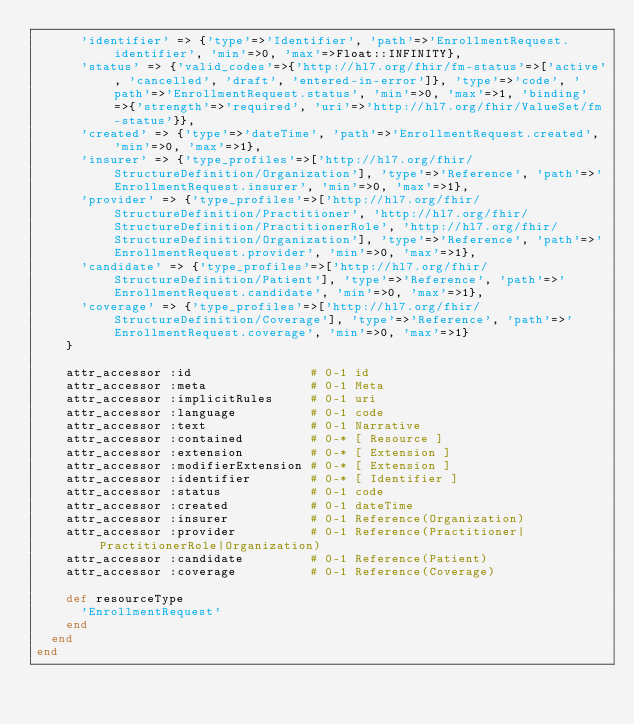<code> <loc_0><loc_0><loc_500><loc_500><_Ruby_>      'identifier' => {'type'=>'Identifier', 'path'=>'EnrollmentRequest.identifier', 'min'=>0, 'max'=>Float::INFINITY},
      'status' => {'valid_codes'=>{'http://hl7.org/fhir/fm-status'=>['active', 'cancelled', 'draft', 'entered-in-error']}, 'type'=>'code', 'path'=>'EnrollmentRequest.status', 'min'=>0, 'max'=>1, 'binding'=>{'strength'=>'required', 'uri'=>'http://hl7.org/fhir/ValueSet/fm-status'}},
      'created' => {'type'=>'dateTime', 'path'=>'EnrollmentRequest.created', 'min'=>0, 'max'=>1},
      'insurer' => {'type_profiles'=>['http://hl7.org/fhir/StructureDefinition/Organization'], 'type'=>'Reference', 'path'=>'EnrollmentRequest.insurer', 'min'=>0, 'max'=>1},
      'provider' => {'type_profiles'=>['http://hl7.org/fhir/StructureDefinition/Practitioner', 'http://hl7.org/fhir/StructureDefinition/PractitionerRole', 'http://hl7.org/fhir/StructureDefinition/Organization'], 'type'=>'Reference', 'path'=>'EnrollmentRequest.provider', 'min'=>0, 'max'=>1},
      'candidate' => {'type_profiles'=>['http://hl7.org/fhir/StructureDefinition/Patient'], 'type'=>'Reference', 'path'=>'EnrollmentRequest.candidate', 'min'=>0, 'max'=>1},
      'coverage' => {'type_profiles'=>['http://hl7.org/fhir/StructureDefinition/Coverage'], 'type'=>'Reference', 'path'=>'EnrollmentRequest.coverage', 'min'=>0, 'max'=>1}
    }

    attr_accessor :id                # 0-1 id
    attr_accessor :meta              # 0-1 Meta
    attr_accessor :implicitRules     # 0-1 uri
    attr_accessor :language          # 0-1 code
    attr_accessor :text              # 0-1 Narrative
    attr_accessor :contained         # 0-* [ Resource ]
    attr_accessor :extension         # 0-* [ Extension ]
    attr_accessor :modifierExtension # 0-* [ Extension ]
    attr_accessor :identifier        # 0-* [ Identifier ]
    attr_accessor :status            # 0-1 code
    attr_accessor :created           # 0-1 dateTime
    attr_accessor :insurer           # 0-1 Reference(Organization)
    attr_accessor :provider          # 0-1 Reference(Practitioner|PractitionerRole|Organization)
    attr_accessor :candidate         # 0-1 Reference(Patient)
    attr_accessor :coverage          # 0-1 Reference(Coverage)

    def resourceType
      'EnrollmentRequest'
    end
  end
end</code> 